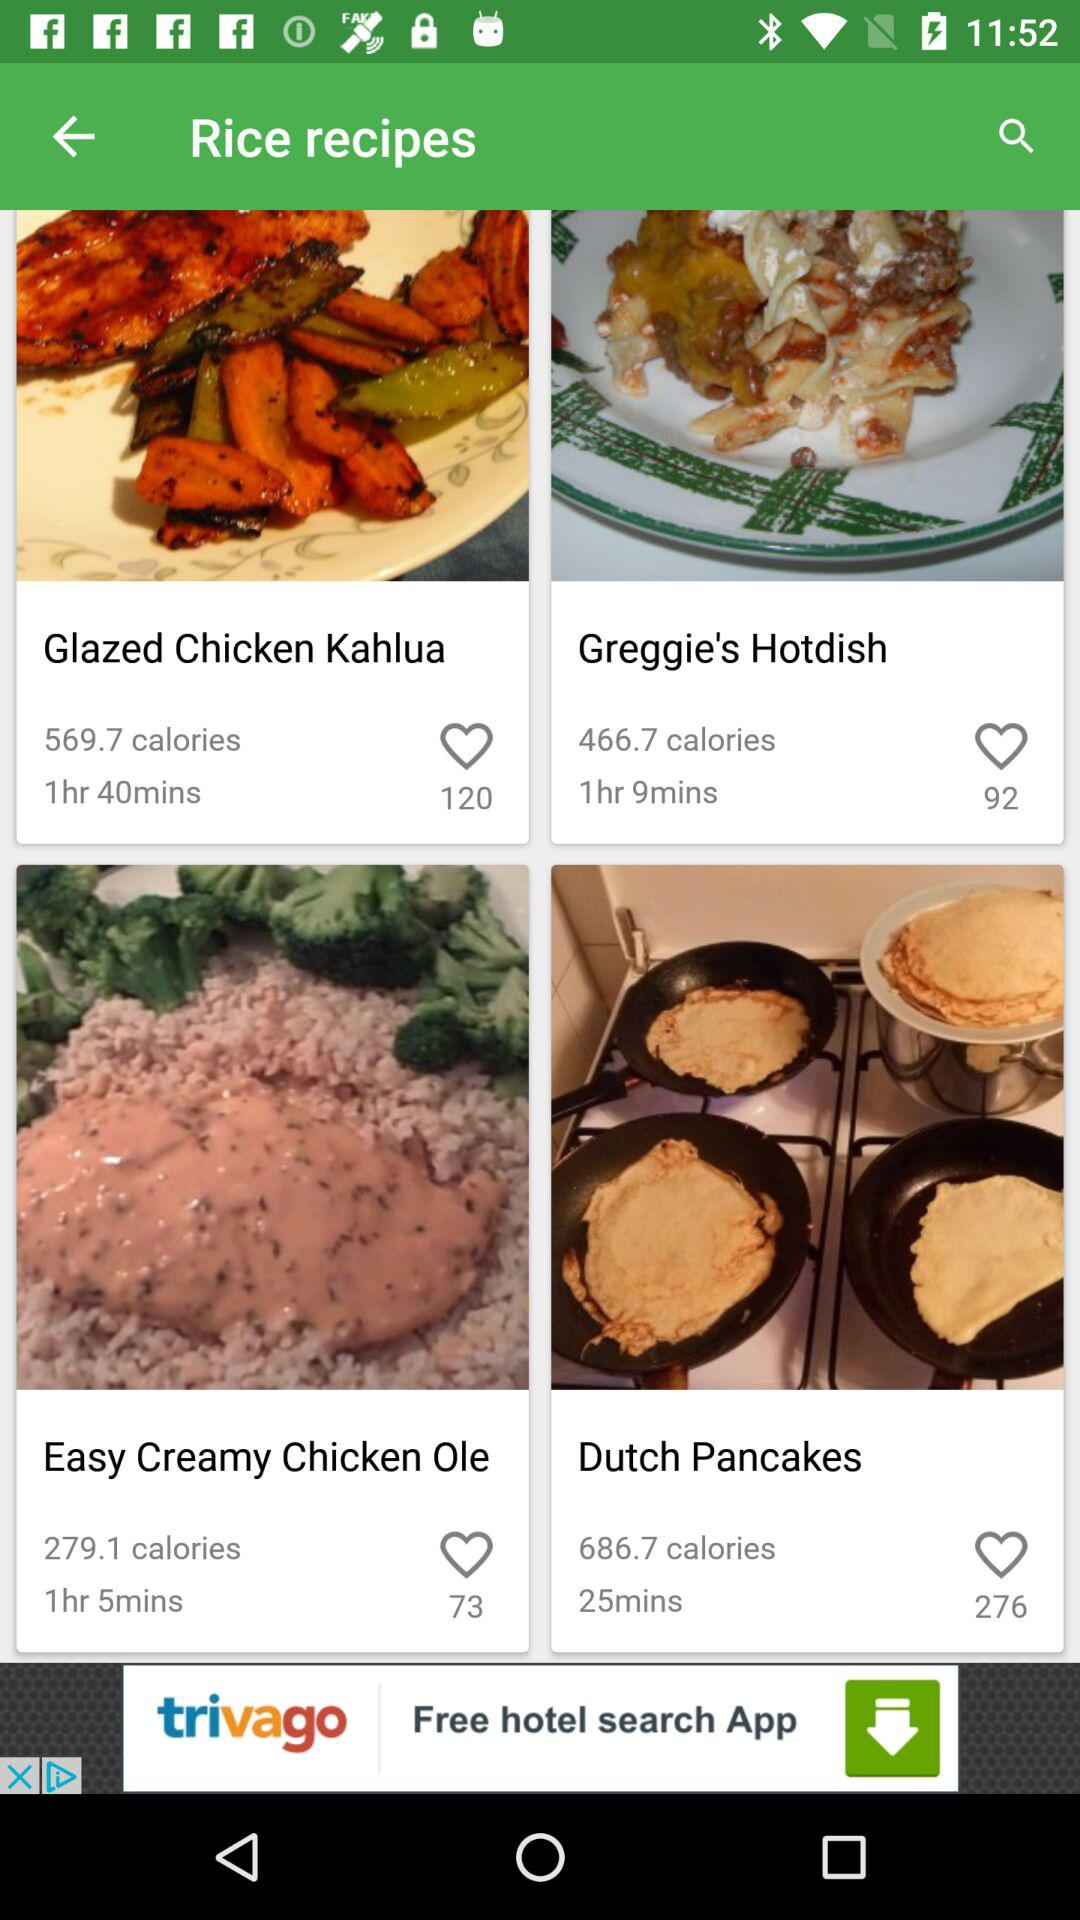How much time is required to prepare "Easy Creamy Chicken Ole"? The required time is 1 hour 5 minutes. 